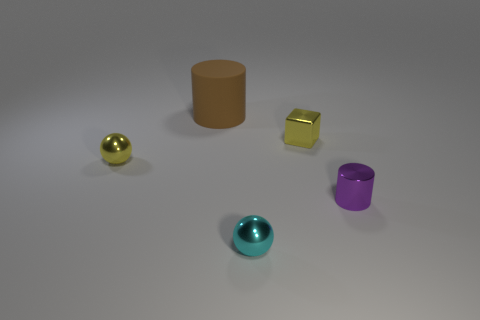What is the material of the sphere that is the same size as the cyan thing?
Provide a short and direct response. Metal. Are the big object and the block made of the same material?
Keep it short and to the point. No. There is a metal thing that is both on the right side of the cyan metallic thing and left of the tiny metallic cylinder; what is its color?
Your answer should be compact. Yellow. There is a tiny ball that is in front of the tiny cylinder; is it the same color as the tiny metallic cube?
Ensure brevity in your answer.  No. What is the shape of the cyan metallic thing that is the same size as the metallic cylinder?
Make the answer very short. Sphere. What number of other things are there of the same color as the tiny metal block?
Ensure brevity in your answer.  1. What number of other objects are the same material as the large brown thing?
Provide a short and direct response. 0. There is a brown object; is it the same size as the yellow object to the left of the cyan metallic object?
Give a very brief answer. No. What is the color of the large rubber thing?
Provide a succinct answer. Brown. What shape is the tiny yellow metal object that is on the left side of the yellow metallic thing on the right side of the small thing to the left of the brown cylinder?
Your answer should be compact. Sphere. 